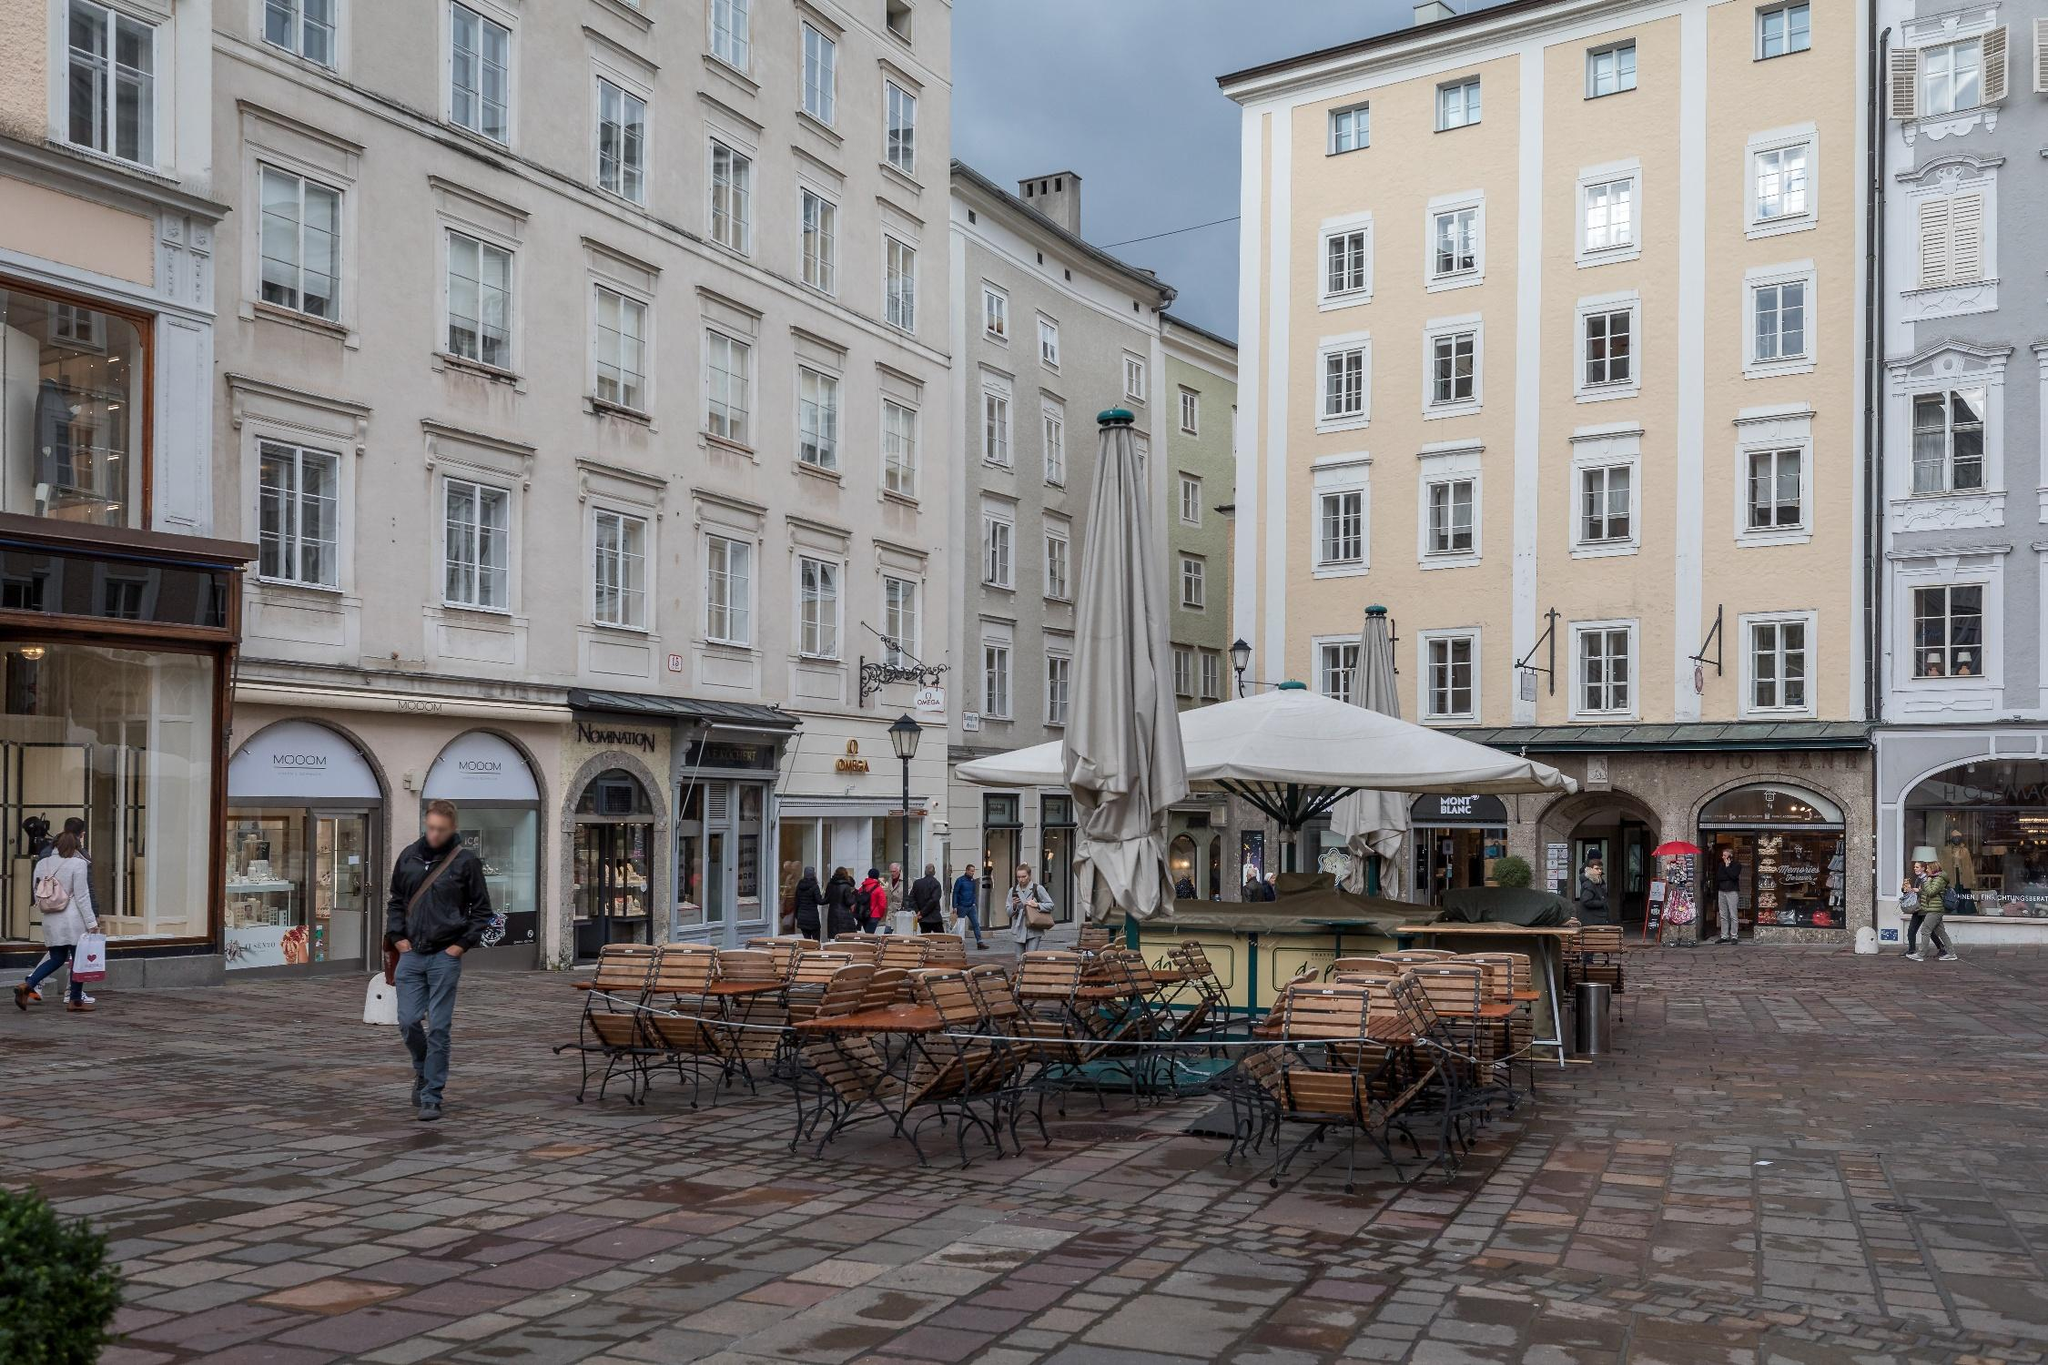What events might take place at this street corner? This street corner is likely a popular location for various activities and events. Consider a bustling farmer’s market taking place here, with vendors setting up stalls around the outdoor seating area, selling local produce, flowers, and homemade goods. On weekends, musicians or street performers might entertain passersby, adding a lively soundtrack to the vibrant scene. The café or restaurant with the outdoor seating would be filled with patrons enjoying coffee, pastries, and conversation. During holidays, the area could be adorned with festive decorations, and local celebrations or parades might pass through, drawing crowds and creating a joyful atmosphere. Do you think this place would be different at night? Absolutely! At night, this street corner would transform into a cozy and illuminated haven. The windows of the buildings might emit a soft, warm glow, and street lamps would cast a gentle light on the cobblestone pavement. The outdoor seating area could become a popular spot for evening diners and those looking to enjoy a late-night drink. The shops might close, but the café or restaurant could remain open, creating a more intimate and relaxed atmosphere. The charm of the architectural details would be highlighted by the night lighting, giving the area a magical and romantic feel. 